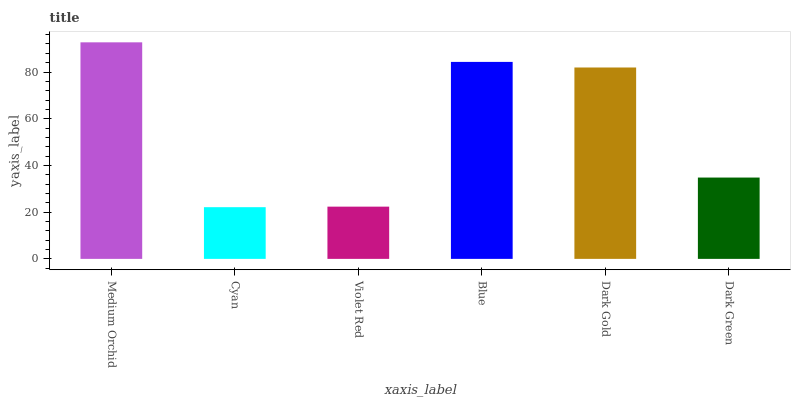Is Violet Red the minimum?
Answer yes or no. No. Is Violet Red the maximum?
Answer yes or no. No. Is Violet Red greater than Cyan?
Answer yes or no. Yes. Is Cyan less than Violet Red?
Answer yes or no. Yes. Is Cyan greater than Violet Red?
Answer yes or no. No. Is Violet Red less than Cyan?
Answer yes or no. No. Is Dark Gold the high median?
Answer yes or no. Yes. Is Dark Green the low median?
Answer yes or no. Yes. Is Medium Orchid the high median?
Answer yes or no. No. Is Violet Red the low median?
Answer yes or no. No. 